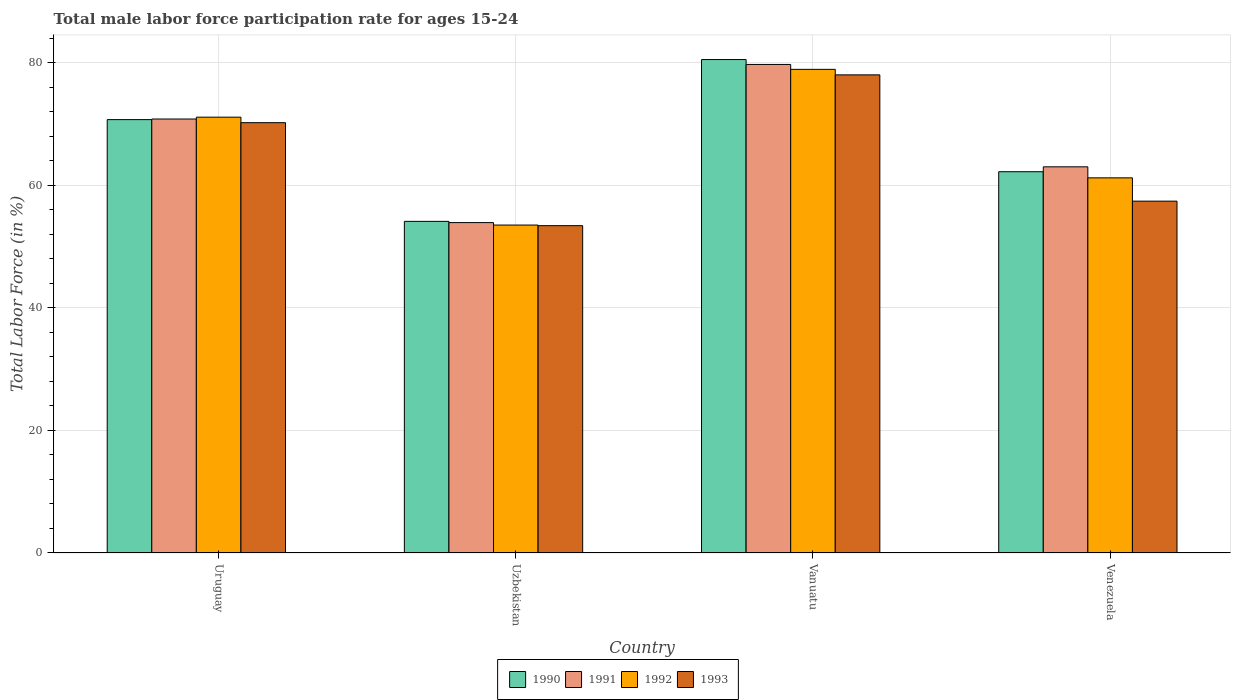How many groups of bars are there?
Offer a very short reply. 4. How many bars are there on the 4th tick from the right?
Provide a succinct answer. 4. What is the label of the 1st group of bars from the left?
Offer a very short reply. Uruguay. What is the male labor force participation rate in 1992 in Venezuela?
Provide a short and direct response. 61.2. Across all countries, what is the maximum male labor force participation rate in 1991?
Give a very brief answer. 79.7. Across all countries, what is the minimum male labor force participation rate in 1992?
Give a very brief answer. 53.5. In which country was the male labor force participation rate in 1991 maximum?
Offer a very short reply. Vanuatu. In which country was the male labor force participation rate in 1993 minimum?
Provide a short and direct response. Uzbekistan. What is the total male labor force participation rate in 1992 in the graph?
Your answer should be very brief. 264.7. What is the difference between the male labor force participation rate in 1992 in Uzbekistan and that in Vanuatu?
Make the answer very short. -25.4. What is the difference between the male labor force participation rate in 1993 in Vanuatu and the male labor force participation rate in 1991 in Uzbekistan?
Your response must be concise. 24.1. What is the average male labor force participation rate in 1990 per country?
Your response must be concise. 66.87. What is the difference between the male labor force participation rate of/in 1992 and male labor force participation rate of/in 1993 in Venezuela?
Your answer should be very brief. 3.8. In how many countries, is the male labor force participation rate in 1990 greater than 40 %?
Your answer should be very brief. 4. What is the ratio of the male labor force participation rate in 1993 in Uzbekistan to that in Vanuatu?
Offer a terse response. 0.68. Is the male labor force participation rate in 1990 in Uzbekistan less than that in Vanuatu?
Give a very brief answer. Yes. What is the difference between the highest and the second highest male labor force participation rate in 1991?
Offer a terse response. -7.8. What is the difference between the highest and the lowest male labor force participation rate in 1991?
Your response must be concise. 25.8. Is the sum of the male labor force participation rate in 1992 in Uruguay and Uzbekistan greater than the maximum male labor force participation rate in 1991 across all countries?
Offer a very short reply. Yes. What does the 3rd bar from the left in Uzbekistan represents?
Provide a short and direct response. 1992. Is it the case that in every country, the sum of the male labor force participation rate in 1990 and male labor force participation rate in 1993 is greater than the male labor force participation rate in 1991?
Keep it short and to the point. Yes. Are all the bars in the graph horizontal?
Offer a terse response. No. Are the values on the major ticks of Y-axis written in scientific E-notation?
Provide a succinct answer. No. Does the graph contain grids?
Your answer should be compact. Yes. Where does the legend appear in the graph?
Ensure brevity in your answer.  Bottom center. How many legend labels are there?
Give a very brief answer. 4. How are the legend labels stacked?
Give a very brief answer. Horizontal. What is the title of the graph?
Make the answer very short. Total male labor force participation rate for ages 15-24. What is the Total Labor Force (in %) in 1990 in Uruguay?
Offer a very short reply. 70.7. What is the Total Labor Force (in %) in 1991 in Uruguay?
Keep it short and to the point. 70.8. What is the Total Labor Force (in %) in 1992 in Uruguay?
Provide a succinct answer. 71.1. What is the Total Labor Force (in %) in 1993 in Uruguay?
Your response must be concise. 70.2. What is the Total Labor Force (in %) in 1990 in Uzbekistan?
Offer a very short reply. 54.1. What is the Total Labor Force (in %) of 1991 in Uzbekistan?
Keep it short and to the point. 53.9. What is the Total Labor Force (in %) in 1992 in Uzbekistan?
Your answer should be very brief. 53.5. What is the Total Labor Force (in %) of 1993 in Uzbekistan?
Offer a terse response. 53.4. What is the Total Labor Force (in %) in 1990 in Vanuatu?
Ensure brevity in your answer.  80.5. What is the Total Labor Force (in %) of 1991 in Vanuatu?
Your answer should be compact. 79.7. What is the Total Labor Force (in %) in 1992 in Vanuatu?
Provide a succinct answer. 78.9. What is the Total Labor Force (in %) in 1993 in Vanuatu?
Keep it short and to the point. 78. What is the Total Labor Force (in %) of 1990 in Venezuela?
Keep it short and to the point. 62.2. What is the Total Labor Force (in %) in 1991 in Venezuela?
Make the answer very short. 63. What is the Total Labor Force (in %) in 1992 in Venezuela?
Your response must be concise. 61.2. What is the Total Labor Force (in %) in 1993 in Venezuela?
Your answer should be compact. 57.4. Across all countries, what is the maximum Total Labor Force (in %) of 1990?
Offer a terse response. 80.5. Across all countries, what is the maximum Total Labor Force (in %) in 1991?
Make the answer very short. 79.7. Across all countries, what is the maximum Total Labor Force (in %) in 1992?
Make the answer very short. 78.9. Across all countries, what is the minimum Total Labor Force (in %) in 1990?
Your response must be concise. 54.1. Across all countries, what is the minimum Total Labor Force (in %) of 1991?
Make the answer very short. 53.9. Across all countries, what is the minimum Total Labor Force (in %) in 1992?
Make the answer very short. 53.5. Across all countries, what is the minimum Total Labor Force (in %) in 1993?
Offer a very short reply. 53.4. What is the total Total Labor Force (in %) of 1990 in the graph?
Offer a very short reply. 267.5. What is the total Total Labor Force (in %) of 1991 in the graph?
Ensure brevity in your answer.  267.4. What is the total Total Labor Force (in %) in 1992 in the graph?
Your answer should be compact. 264.7. What is the total Total Labor Force (in %) in 1993 in the graph?
Give a very brief answer. 259. What is the difference between the Total Labor Force (in %) in 1990 in Uruguay and that in Uzbekistan?
Keep it short and to the point. 16.6. What is the difference between the Total Labor Force (in %) in 1991 in Uruguay and that in Uzbekistan?
Offer a very short reply. 16.9. What is the difference between the Total Labor Force (in %) of 1991 in Uruguay and that in Vanuatu?
Keep it short and to the point. -8.9. What is the difference between the Total Labor Force (in %) in 1992 in Uruguay and that in Vanuatu?
Your answer should be compact. -7.8. What is the difference between the Total Labor Force (in %) of 1990 in Uzbekistan and that in Vanuatu?
Offer a terse response. -26.4. What is the difference between the Total Labor Force (in %) of 1991 in Uzbekistan and that in Vanuatu?
Ensure brevity in your answer.  -25.8. What is the difference between the Total Labor Force (in %) of 1992 in Uzbekistan and that in Vanuatu?
Your response must be concise. -25.4. What is the difference between the Total Labor Force (in %) in 1993 in Uzbekistan and that in Vanuatu?
Provide a succinct answer. -24.6. What is the difference between the Total Labor Force (in %) in 1991 in Uzbekistan and that in Venezuela?
Your answer should be very brief. -9.1. What is the difference between the Total Labor Force (in %) in 1992 in Uzbekistan and that in Venezuela?
Give a very brief answer. -7.7. What is the difference between the Total Labor Force (in %) of 1993 in Uzbekistan and that in Venezuela?
Your answer should be very brief. -4. What is the difference between the Total Labor Force (in %) of 1990 in Vanuatu and that in Venezuela?
Make the answer very short. 18.3. What is the difference between the Total Labor Force (in %) in 1991 in Vanuatu and that in Venezuela?
Your answer should be compact. 16.7. What is the difference between the Total Labor Force (in %) of 1992 in Vanuatu and that in Venezuela?
Offer a terse response. 17.7. What is the difference between the Total Labor Force (in %) in 1993 in Vanuatu and that in Venezuela?
Ensure brevity in your answer.  20.6. What is the difference between the Total Labor Force (in %) in 1990 in Uruguay and the Total Labor Force (in %) in 1991 in Uzbekistan?
Your response must be concise. 16.8. What is the difference between the Total Labor Force (in %) of 1990 in Uruguay and the Total Labor Force (in %) of 1993 in Uzbekistan?
Offer a very short reply. 17.3. What is the difference between the Total Labor Force (in %) of 1991 in Uruguay and the Total Labor Force (in %) of 1993 in Uzbekistan?
Keep it short and to the point. 17.4. What is the difference between the Total Labor Force (in %) of 1992 in Uruguay and the Total Labor Force (in %) of 1993 in Uzbekistan?
Your answer should be compact. 17.7. What is the difference between the Total Labor Force (in %) in 1990 in Uruguay and the Total Labor Force (in %) in 1992 in Vanuatu?
Offer a very short reply. -8.2. What is the difference between the Total Labor Force (in %) of 1991 in Uruguay and the Total Labor Force (in %) of 1992 in Vanuatu?
Provide a short and direct response. -8.1. What is the difference between the Total Labor Force (in %) of 1990 in Uruguay and the Total Labor Force (in %) of 1991 in Venezuela?
Your answer should be compact. 7.7. What is the difference between the Total Labor Force (in %) in 1990 in Uruguay and the Total Labor Force (in %) in 1993 in Venezuela?
Make the answer very short. 13.3. What is the difference between the Total Labor Force (in %) of 1991 in Uruguay and the Total Labor Force (in %) of 1992 in Venezuela?
Your answer should be compact. 9.6. What is the difference between the Total Labor Force (in %) of 1992 in Uruguay and the Total Labor Force (in %) of 1993 in Venezuela?
Offer a very short reply. 13.7. What is the difference between the Total Labor Force (in %) of 1990 in Uzbekistan and the Total Labor Force (in %) of 1991 in Vanuatu?
Provide a succinct answer. -25.6. What is the difference between the Total Labor Force (in %) in 1990 in Uzbekistan and the Total Labor Force (in %) in 1992 in Vanuatu?
Ensure brevity in your answer.  -24.8. What is the difference between the Total Labor Force (in %) in 1990 in Uzbekistan and the Total Labor Force (in %) in 1993 in Vanuatu?
Offer a terse response. -23.9. What is the difference between the Total Labor Force (in %) of 1991 in Uzbekistan and the Total Labor Force (in %) of 1993 in Vanuatu?
Keep it short and to the point. -24.1. What is the difference between the Total Labor Force (in %) of 1992 in Uzbekistan and the Total Labor Force (in %) of 1993 in Vanuatu?
Keep it short and to the point. -24.5. What is the difference between the Total Labor Force (in %) in 1990 in Uzbekistan and the Total Labor Force (in %) in 1993 in Venezuela?
Your response must be concise. -3.3. What is the difference between the Total Labor Force (in %) in 1991 in Uzbekistan and the Total Labor Force (in %) in 1992 in Venezuela?
Your response must be concise. -7.3. What is the difference between the Total Labor Force (in %) of 1991 in Uzbekistan and the Total Labor Force (in %) of 1993 in Venezuela?
Offer a very short reply. -3.5. What is the difference between the Total Labor Force (in %) in 1990 in Vanuatu and the Total Labor Force (in %) in 1991 in Venezuela?
Provide a succinct answer. 17.5. What is the difference between the Total Labor Force (in %) of 1990 in Vanuatu and the Total Labor Force (in %) of 1992 in Venezuela?
Provide a short and direct response. 19.3. What is the difference between the Total Labor Force (in %) in 1990 in Vanuatu and the Total Labor Force (in %) in 1993 in Venezuela?
Your response must be concise. 23.1. What is the difference between the Total Labor Force (in %) in 1991 in Vanuatu and the Total Labor Force (in %) in 1992 in Venezuela?
Offer a terse response. 18.5. What is the difference between the Total Labor Force (in %) in 1991 in Vanuatu and the Total Labor Force (in %) in 1993 in Venezuela?
Your answer should be very brief. 22.3. What is the difference between the Total Labor Force (in %) of 1992 in Vanuatu and the Total Labor Force (in %) of 1993 in Venezuela?
Give a very brief answer. 21.5. What is the average Total Labor Force (in %) in 1990 per country?
Your answer should be compact. 66.88. What is the average Total Labor Force (in %) in 1991 per country?
Keep it short and to the point. 66.85. What is the average Total Labor Force (in %) of 1992 per country?
Your answer should be compact. 66.17. What is the average Total Labor Force (in %) of 1993 per country?
Provide a short and direct response. 64.75. What is the difference between the Total Labor Force (in %) of 1991 and Total Labor Force (in %) of 1993 in Uruguay?
Your response must be concise. 0.6. What is the difference between the Total Labor Force (in %) of 1992 and Total Labor Force (in %) of 1993 in Uruguay?
Make the answer very short. 0.9. What is the difference between the Total Labor Force (in %) in 1990 and Total Labor Force (in %) in 1991 in Uzbekistan?
Offer a very short reply. 0.2. What is the difference between the Total Labor Force (in %) in 1990 and Total Labor Force (in %) in 1992 in Uzbekistan?
Provide a succinct answer. 0.6. What is the difference between the Total Labor Force (in %) in 1991 and Total Labor Force (in %) in 1992 in Uzbekistan?
Ensure brevity in your answer.  0.4. What is the difference between the Total Labor Force (in %) in 1992 and Total Labor Force (in %) in 1993 in Uzbekistan?
Provide a short and direct response. 0.1. What is the difference between the Total Labor Force (in %) of 1990 and Total Labor Force (in %) of 1992 in Vanuatu?
Offer a very short reply. 1.6. What is the difference between the Total Labor Force (in %) of 1991 and Total Labor Force (in %) of 1992 in Vanuatu?
Provide a succinct answer. 0.8. What is the difference between the Total Labor Force (in %) of 1990 and Total Labor Force (in %) of 1991 in Venezuela?
Your response must be concise. -0.8. What is the difference between the Total Labor Force (in %) in 1990 and Total Labor Force (in %) in 1992 in Venezuela?
Your answer should be compact. 1. What is the difference between the Total Labor Force (in %) in 1991 and Total Labor Force (in %) in 1992 in Venezuela?
Your response must be concise. 1.8. What is the ratio of the Total Labor Force (in %) in 1990 in Uruguay to that in Uzbekistan?
Make the answer very short. 1.31. What is the ratio of the Total Labor Force (in %) in 1991 in Uruguay to that in Uzbekistan?
Offer a terse response. 1.31. What is the ratio of the Total Labor Force (in %) in 1992 in Uruguay to that in Uzbekistan?
Your answer should be very brief. 1.33. What is the ratio of the Total Labor Force (in %) of 1993 in Uruguay to that in Uzbekistan?
Your answer should be very brief. 1.31. What is the ratio of the Total Labor Force (in %) in 1990 in Uruguay to that in Vanuatu?
Offer a very short reply. 0.88. What is the ratio of the Total Labor Force (in %) of 1991 in Uruguay to that in Vanuatu?
Provide a succinct answer. 0.89. What is the ratio of the Total Labor Force (in %) of 1992 in Uruguay to that in Vanuatu?
Keep it short and to the point. 0.9. What is the ratio of the Total Labor Force (in %) of 1993 in Uruguay to that in Vanuatu?
Offer a very short reply. 0.9. What is the ratio of the Total Labor Force (in %) in 1990 in Uruguay to that in Venezuela?
Ensure brevity in your answer.  1.14. What is the ratio of the Total Labor Force (in %) in 1991 in Uruguay to that in Venezuela?
Keep it short and to the point. 1.12. What is the ratio of the Total Labor Force (in %) of 1992 in Uruguay to that in Venezuela?
Your answer should be compact. 1.16. What is the ratio of the Total Labor Force (in %) in 1993 in Uruguay to that in Venezuela?
Provide a succinct answer. 1.22. What is the ratio of the Total Labor Force (in %) of 1990 in Uzbekistan to that in Vanuatu?
Provide a short and direct response. 0.67. What is the ratio of the Total Labor Force (in %) of 1991 in Uzbekistan to that in Vanuatu?
Offer a terse response. 0.68. What is the ratio of the Total Labor Force (in %) in 1992 in Uzbekistan to that in Vanuatu?
Provide a succinct answer. 0.68. What is the ratio of the Total Labor Force (in %) in 1993 in Uzbekistan to that in Vanuatu?
Offer a very short reply. 0.68. What is the ratio of the Total Labor Force (in %) of 1990 in Uzbekistan to that in Venezuela?
Keep it short and to the point. 0.87. What is the ratio of the Total Labor Force (in %) of 1991 in Uzbekistan to that in Venezuela?
Give a very brief answer. 0.86. What is the ratio of the Total Labor Force (in %) in 1992 in Uzbekistan to that in Venezuela?
Ensure brevity in your answer.  0.87. What is the ratio of the Total Labor Force (in %) of 1993 in Uzbekistan to that in Venezuela?
Your answer should be very brief. 0.93. What is the ratio of the Total Labor Force (in %) in 1990 in Vanuatu to that in Venezuela?
Keep it short and to the point. 1.29. What is the ratio of the Total Labor Force (in %) of 1991 in Vanuatu to that in Venezuela?
Give a very brief answer. 1.27. What is the ratio of the Total Labor Force (in %) in 1992 in Vanuatu to that in Venezuela?
Offer a very short reply. 1.29. What is the ratio of the Total Labor Force (in %) in 1993 in Vanuatu to that in Venezuela?
Keep it short and to the point. 1.36. What is the difference between the highest and the second highest Total Labor Force (in %) in 1990?
Ensure brevity in your answer.  9.8. What is the difference between the highest and the second highest Total Labor Force (in %) of 1991?
Ensure brevity in your answer.  8.9. What is the difference between the highest and the second highest Total Labor Force (in %) of 1993?
Your answer should be very brief. 7.8. What is the difference between the highest and the lowest Total Labor Force (in %) of 1990?
Give a very brief answer. 26.4. What is the difference between the highest and the lowest Total Labor Force (in %) in 1991?
Give a very brief answer. 25.8. What is the difference between the highest and the lowest Total Labor Force (in %) of 1992?
Provide a short and direct response. 25.4. What is the difference between the highest and the lowest Total Labor Force (in %) in 1993?
Your answer should be very brief. 24.6. 